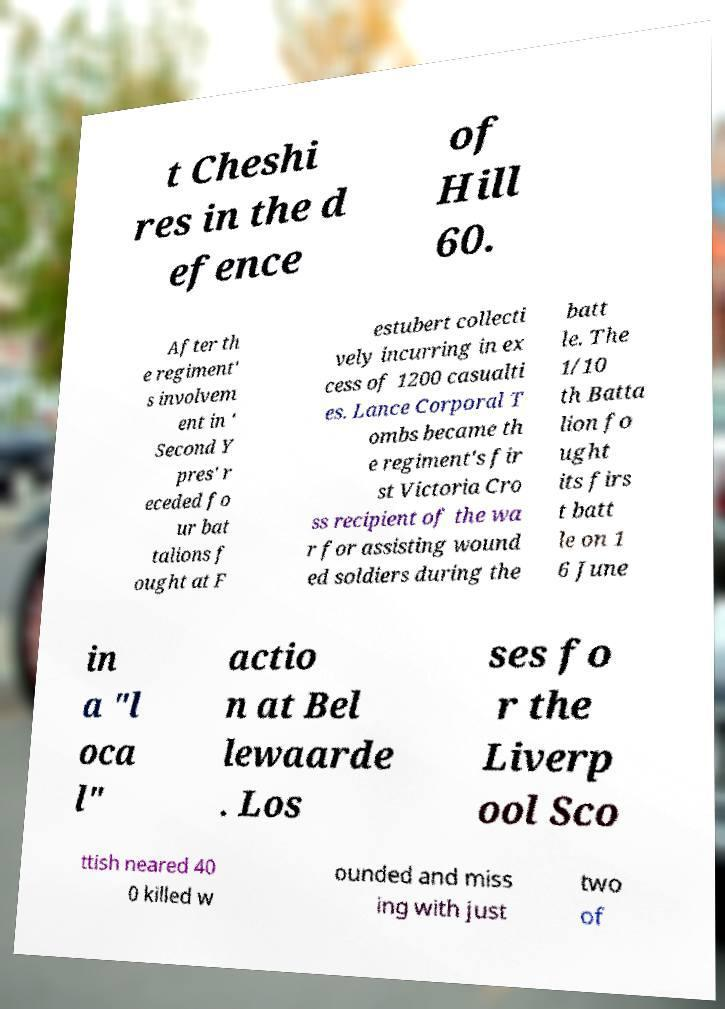Please identify and transcribe the text found in this image. t Cheshi res in the d efence of Hill 60. After th e regiment' s involvem ent in ' Second Y pres' r eceded fo ur bat talions f ought at F estubert collecti vely incurring in ex cess of 1200 casualti es. Lance Corporal T ombs became th e regiment's fir st Victoria Cro ss recipient of the wa r for assisting wound ed soldiers during the batt le. The 1/10 th Batta lion fo ught its firs t batt le on 1 6 June in a "l oca l" actio n at Bel lewaarde . Los ses fo r the Liverp ool Sco ttish neared 40 0 killed w ounded and miss ing with just two of 